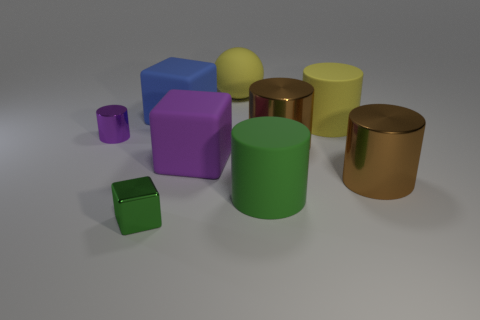How many objects in total can be counted in this image? There are a total of nine objects, including various geometric shapes such as cylinders, cubes, and a prism, each varying in size and color. 